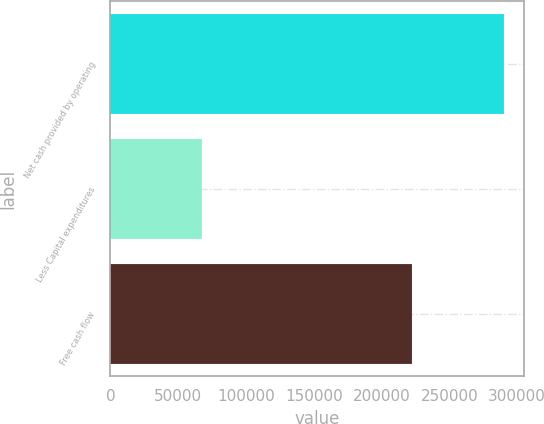<chart> <loc_0><loc_0><loc_500><loc_500><bar_chart><fcel>Net cash provided by operating<fcel>Less Capital expenditures<fcel>Free cash flow<nl><fcel>290241<fcel>67571<fcel>222670<nl></chart> 